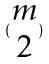<formula> <loc_0><loc_0><loc_500><loc_500>( \begin{matrix} m \\ 2 \end{matrix} )</formula> 